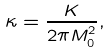Convert formula to latex. <formula><loc_0><loc_0><loc_500><loc_500>\kappa = \frac { K } { 2 \pi M _ { 0 } ^ { 2 } } ,</formula> 